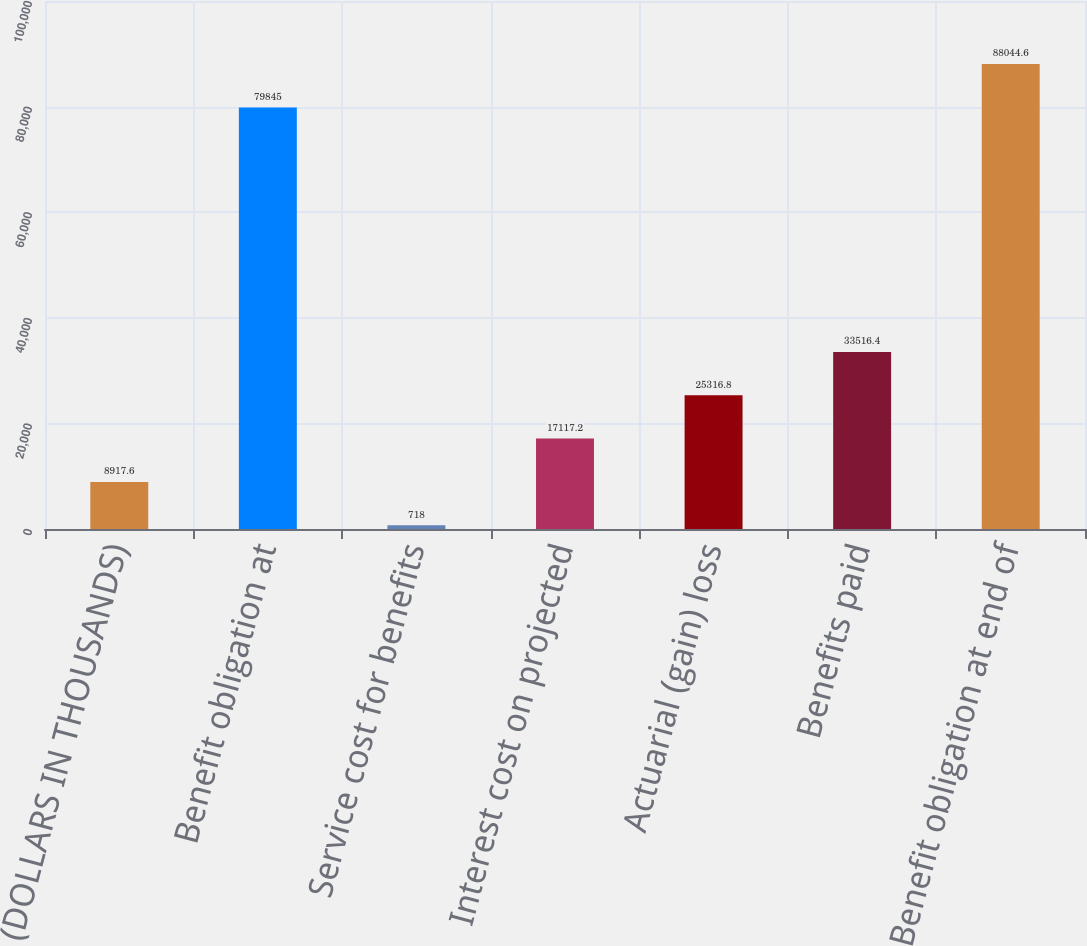<chart> <loc_0><loc_0><loc_500><loc_500><bar_chart><fcel>(DOLLARS IN THOUSANDS)<fcel>Benefit obligation at<fcel>Service cost for benefits<fcel>Interest cost on projected<fcel>Actuarial (gain) loss<fcel>Benefits paid<fcel>Benefit obligation at end of<nl><fcel>8917.6<fcel>79845<fcel>718<fcel>17117.2<fcel>25316.8<fcel>33516.4<fcel>88044.6<nl></chart> 